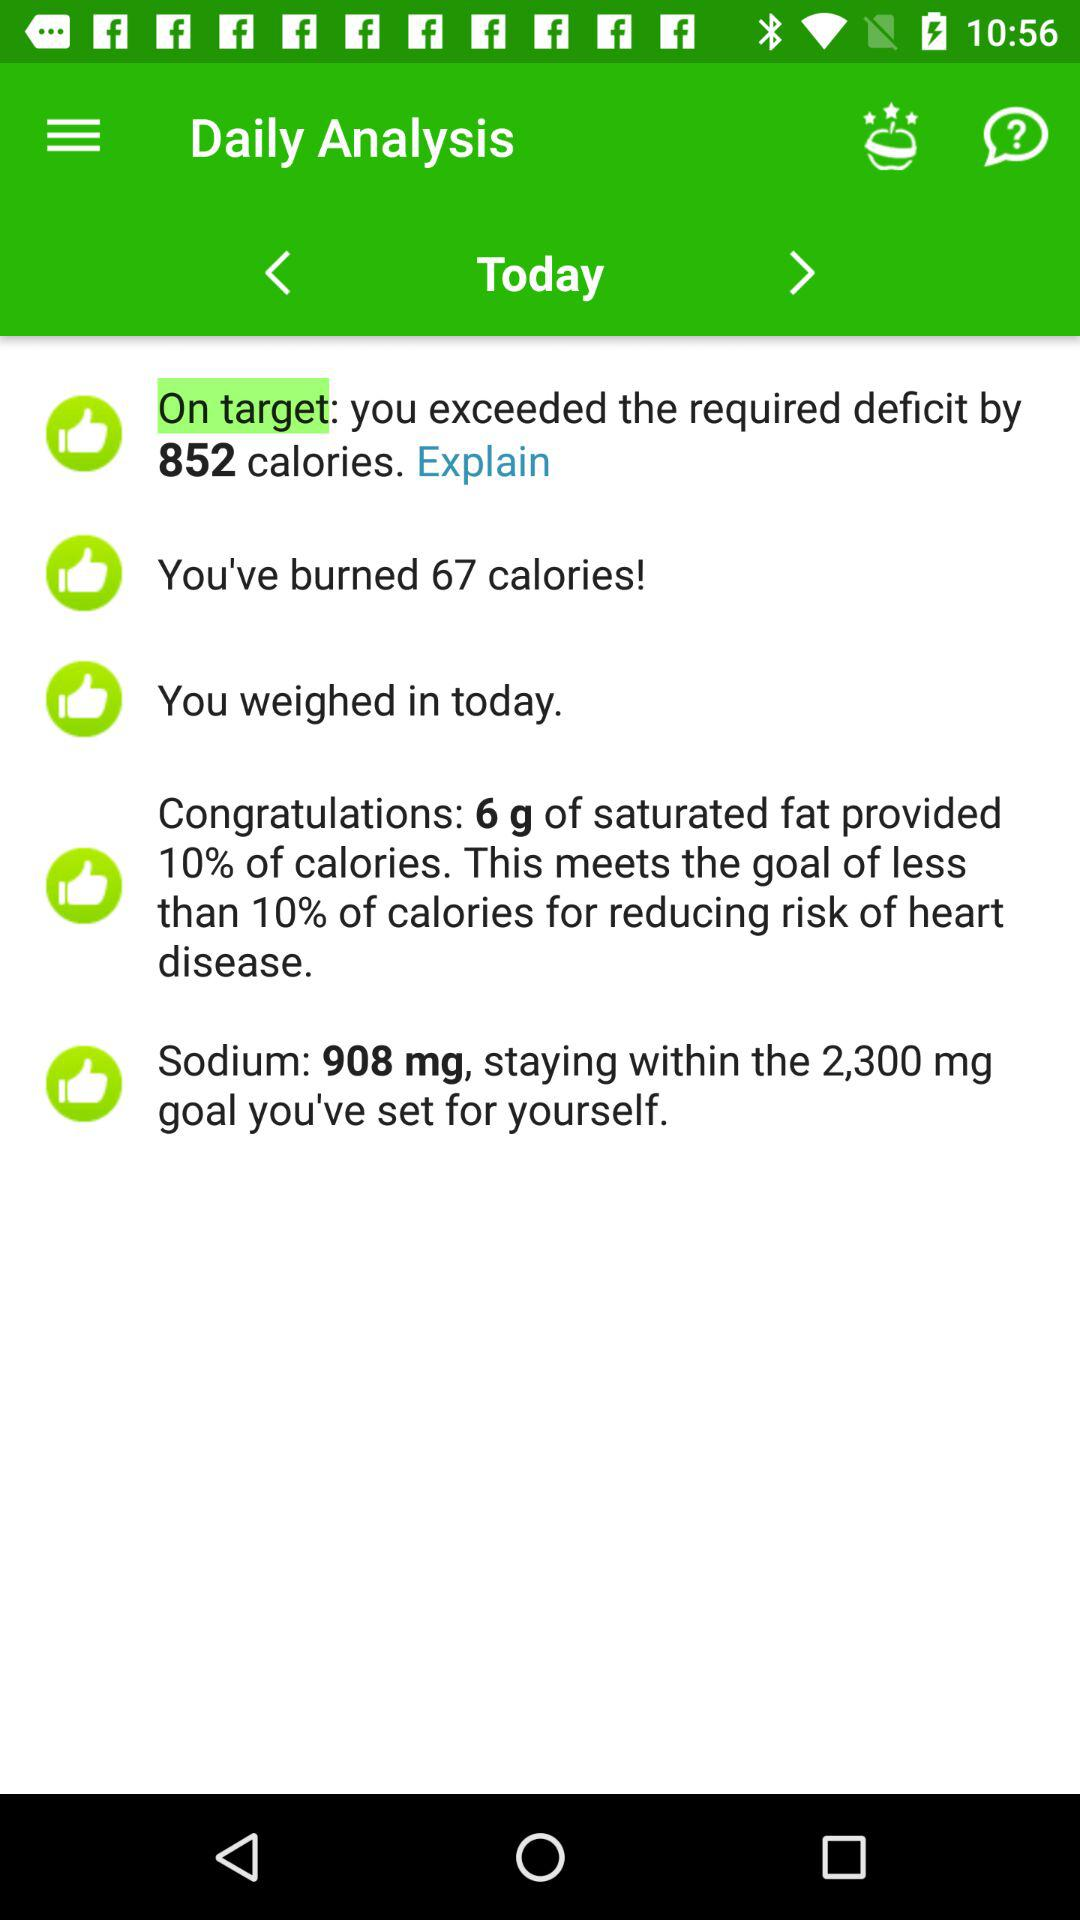What percentage of calories are provided by 6 g of saturated fat? There are 10 percent of calories provided by 6 g of saturated fat. 